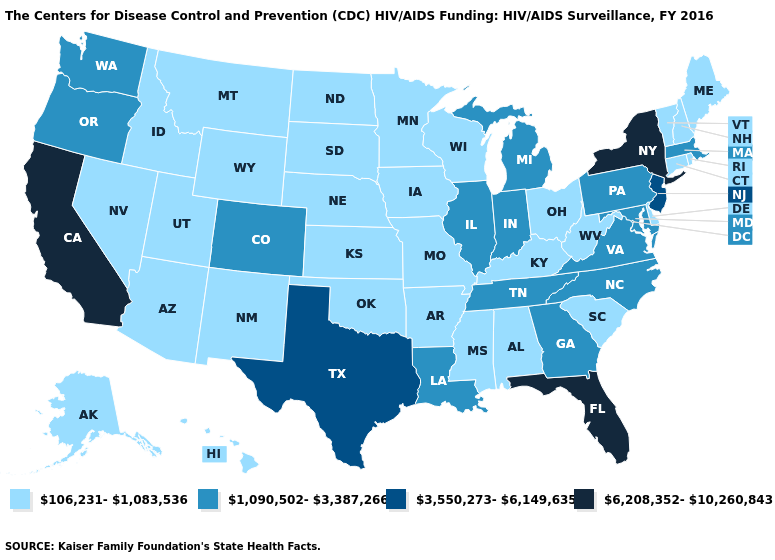Does the first symbol in the legend represent the smallest category?
Quick response, please. Yes. What is the highest value in states that border South Dakota?
Be succinct. 106,231-1,083,536. What is the value of Nebraska?
Write a very short answer. 106,231-1,083,536. Among the states that border West Virginia , does Virginia have the lowest value?
Write a very short answer. No. Does Connecticut have the lowest value in the Northeast?
Keep it brief. Yes. What is the highest value in the West ?
Concise answer only. 6,208,352-10,260,843. Does Michigan have a higher value than Delaware?
Be succinct. Yes. What is the lowest value in states that border Ohio?
Keep it brief. 106,231-1,083,536. Which states have the lowest value in the USA?
Quick response, please. Alabama, Alaska, Arizona, Arkansas, Connecticut, Delaware, Hawaii, Idaho, Iowa, Kansas, Kentucky, Maine, Minnesota, Mississippi, Missouri, Montana, Nebraska, Nevada, New Hampshire, New Mexico, North Dakota, Ohio, Oklahoma, Rhode Island, South Carolina, South Dakota, Utah, Vermont, West Virginia, Wisconsin, Wyoming. Name the states that have a value in the range 3,550,273-6,149,635?
Be succinct. New Jersey, Texas. Is the legend a continuous bar?
Quick response, please. No. Among the states that border South Carolina , which have the lowest value?
Be succinct. Georgia, North Carolina. Does New Hampshire have the same value as Michigan?
Give a very brief answer. No. Does California have the highest value in the USA?
Quick response, please. Yes. 